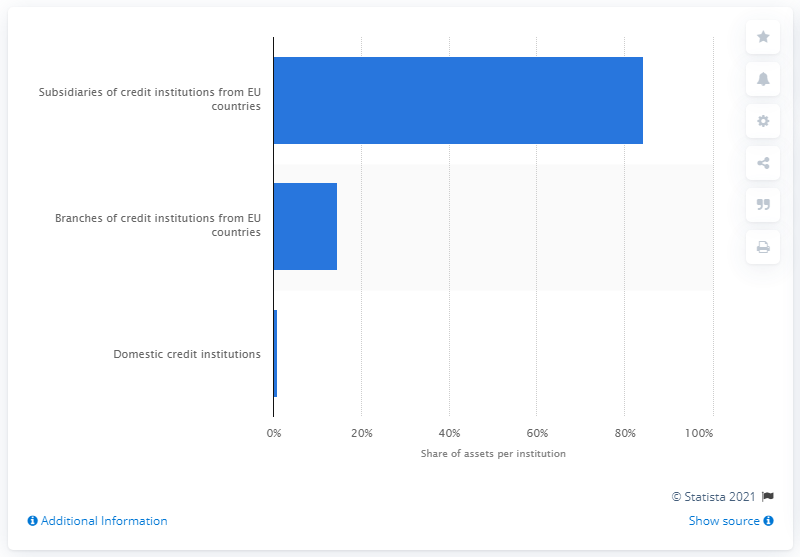Identify some key points in this picture. In 2016, 84.3% of Slovakia's banking assets were held by subsidiaries of EU credit institutions. 